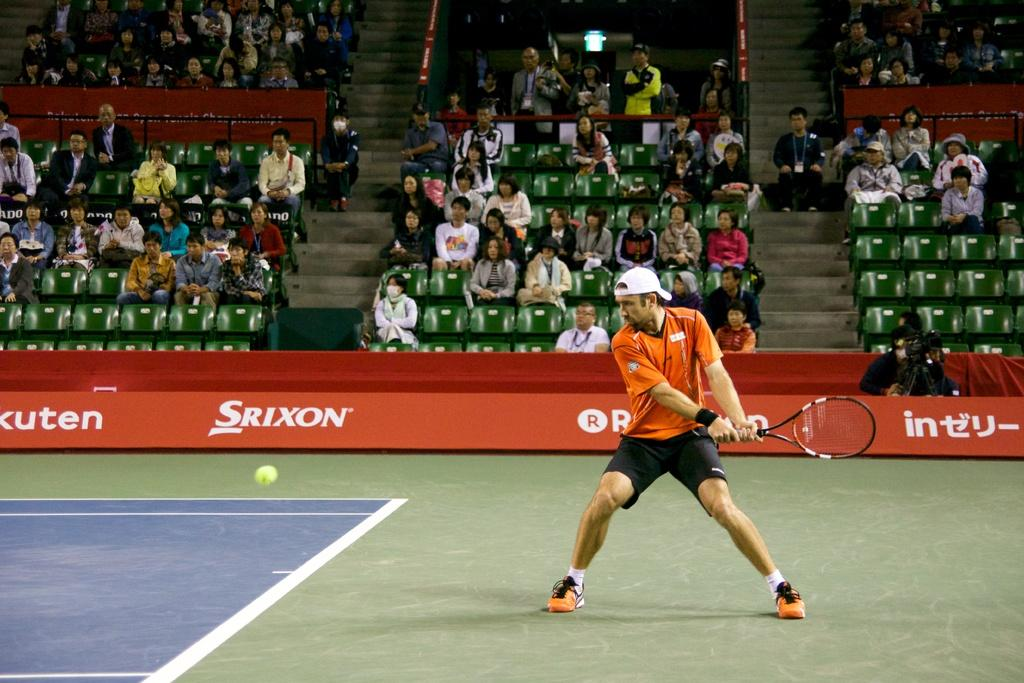Provide a one-sentence caption for the provided image. A tennis player waiting to return the ball in front of a Srixon advertisement. 